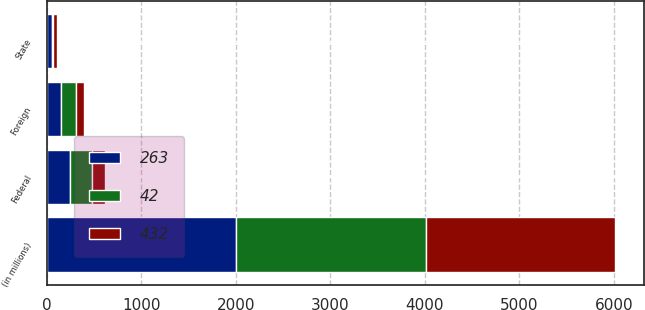Convert chart to OTSL. <chart><loc_0><loc_0><loc_500><loc_500><stacked_bar_chart><ecel><fcel>(in millions)<fcel>Federal<fcel>State<fcel>Foreign<nl><fcel>263<fcel>2006<fcel>251<fcel>53<fcel>158<nl><fcel>432<fcel>2005<fcel>136<fcel>37<fcel>86<nl><fcel>42<fcel>2004<fcel>233<fcel>20<fcel>149<nl></chart> 